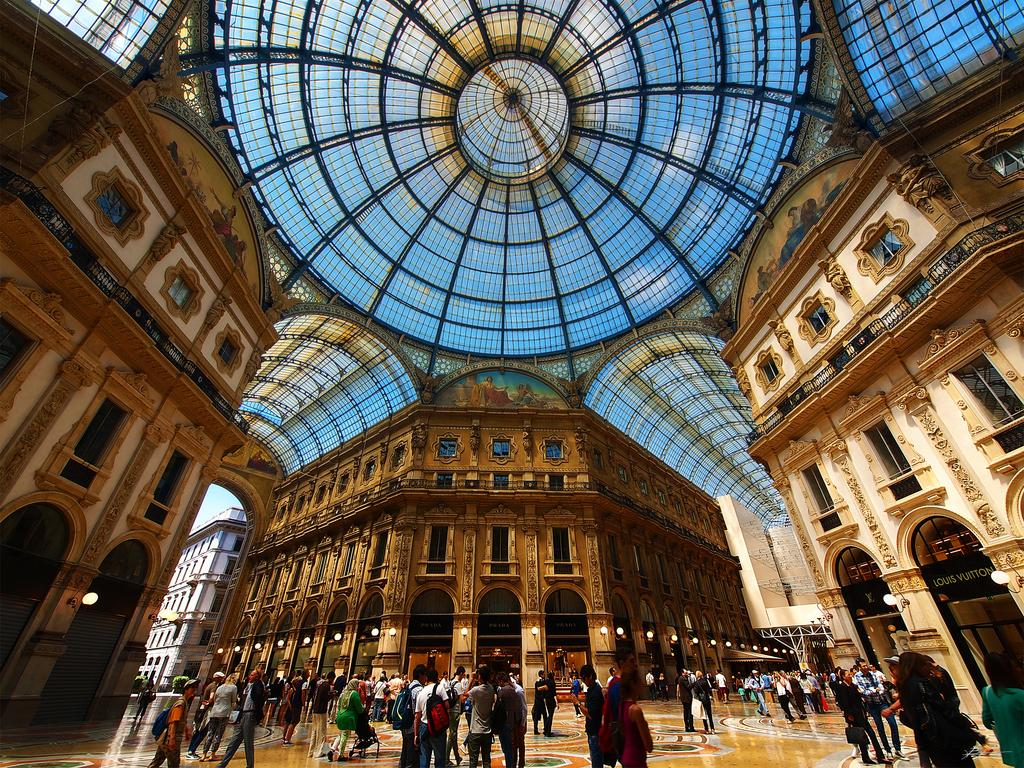How many buildings are visible in the image? There are three buildings in the image. What feature do the buildings share? The buildings are connected by a big roof. What activity is taking place in the middle of the image? People are walking in the middle of the image. What type of plate is being used by the cat in the image? There is no cat or plate present in the image. 